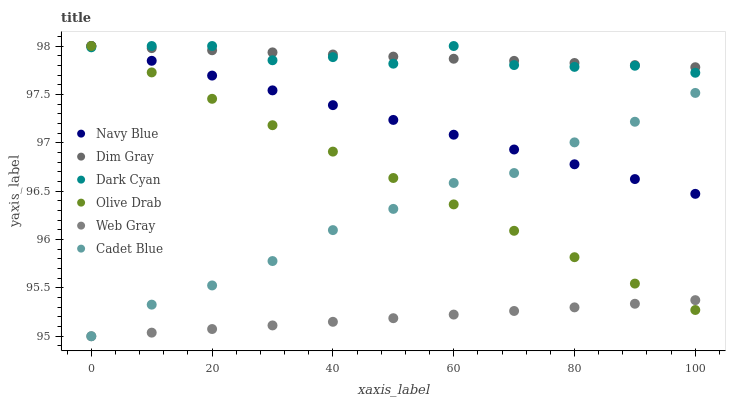Does Web Gray have the minimum area under the curve?
Answer yes or no. Yes. Does Dim Gray have the maximum area under the curve?
Answer yes or no. Yes. Does Navy Blue have the minimum area under the curve?
Answer yes or no. No. Does Navy Blue have the maximum area under the curve?
Answer yes or no. No. Is Web Gray the smoothest?
Answer yes or no. Yes. Is Dark Cyan the roughest?
Answer yes or no. Yes. Is Navy Blue the smoothest?
Answer yes or no. No. Is Navy Blue the roughest?
Answer yes or no. No. Does Cadet Blue have the lowest value?
Answer yes or no. Yes. Does Navy Blue have the lowest value?
Answer yes or no. No. Does Olive Drab have the highest value?
Answer yes or no. Yes. Does Web Gray have the highest value?
Answer yes or no. No. Is Cadet Blue less than Dark Cyan?
Answer yes or no. Yes. Is Navy Blue greater than Web Gray?
Answer yes or no. Yes. Does Olive Drab intersect Web Gray?
Answer yes or no. Yes. Is Olive Drab less than Web Gray?
Answer yes or no. No. Is Olive Drab greater than Web Gray?
Answer yes or no. No. Does Cadet Blue intersect Dark Cyan?
Answer yes or no. No. 